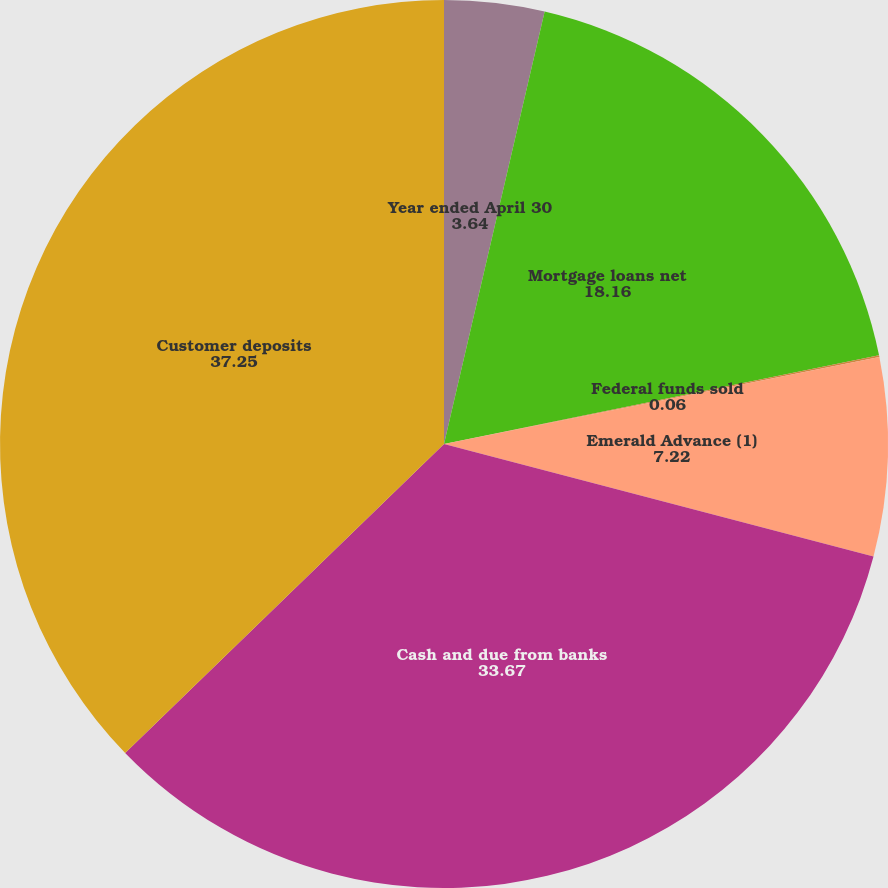<chart> <loc_0><loc_0><loc_500><loc_500><pie_chart><fcel>Year ended April 30<fcel>Mortgage loans net<fcel>Federal funds sold<fcel>Emerald Advance (1)<fcel>Cash and due from banks<fcel>Customer deposits<nl><fcel>3.64%<fcel>18.16%<fcel>0.06%<fcel>7.22%<fcel>33.67%<fcel>37.25%<nl></chart> 